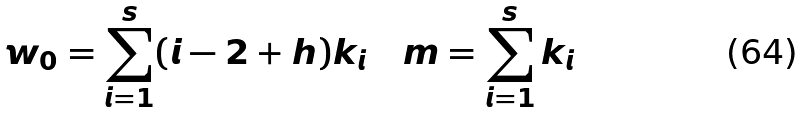Convert formula to latex. <formula><loc_0><loc_0><loc_500><loc_500>w _ { 0 } = \sum _ { i = 1 } ^ { s } ( i - 2 + h ) k _ { i } \quad m = \sum _ { i = 1 } ^ { s } k _ { i }</formula> 